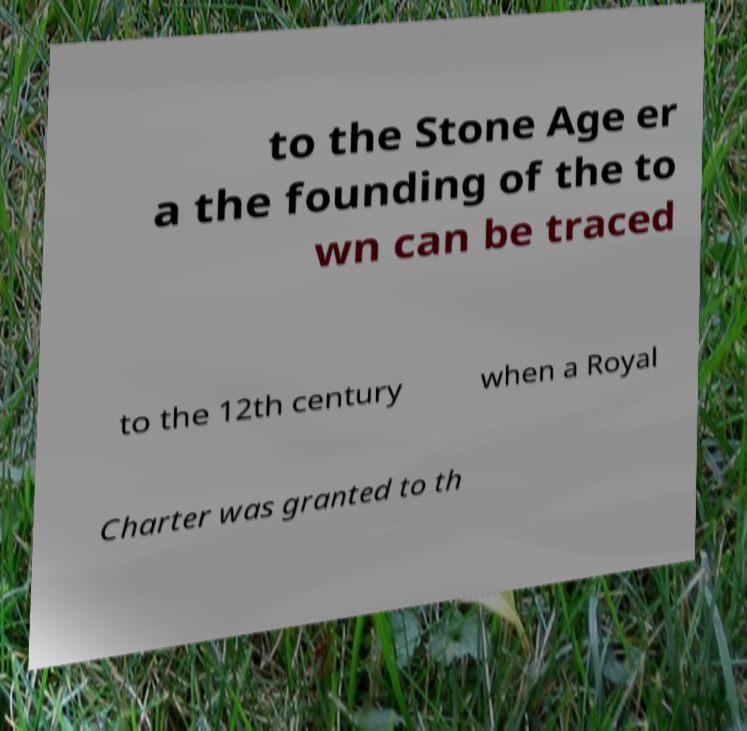What messages or text are displayed in this image? I need them in a readable, typed format. to the Stone Age er a the founding of the to wn can be traced to the 12th century when a Royal Charter was granted to th 